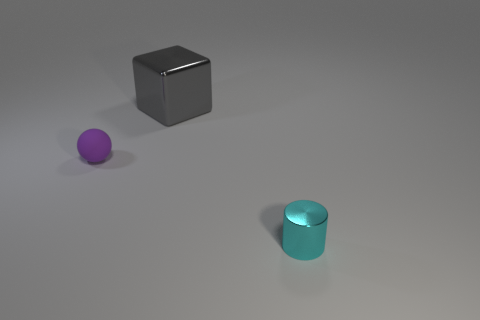Add 1 cyan metal cylinders. How many objects exist? 4 Subtract all balls. How many objects are left? 2 Subtract all big brown rubber cylinders. Subtract all small things. How many objects are left? 1 Add 3 large gray blocks. How many large gray blocks are left? 4 Add 2 cyan objects. How many cyan objects exist? 3 Subtract 1 purple spheres. How many objects are left? 2 